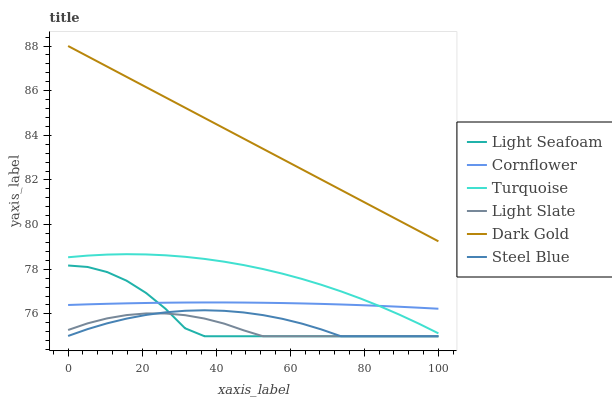Does Light Slate have the minimum area under the curve?
Answer yes or no. Yes. Does Dark Gold have the maximum area under the curve?
Answer yes or no. Yes. Does Turquoise have the minimum area under the curve?
Answer yes or no. No. Does Turquoise have the maximum area under the curve?
Answer yes or no. No. Is Dark Gold the smoothest?
Answer yes or no. Yes. Is Light Seafoam the roughest?
Answer yes or no. Yes. Is Turquoise the smoothest?
Answer yes or no. No. Is Turquoise the roughest?
Answer yes or no. No. Does Light Slate have the lowest value?
Answer yes or no. Yes. Does Turquoise have the lowest value?
Answer yes or no. No. Does Dark Gold have the highest value?
Answer yes or no. Yes. Does Turquoise have the highest value?
Answer yes or no. No. Is Steel Blue less than Cornflower?
Answer yes or no. Yes. Is Cornflower greater than Steel Blue?
Answer yes or no. Yes. Does Steel Blue intersect Light Seafoam?
Answer yes or no. Yes. Is Steel Blue less than Light Seafoam?
Answer yes or no. No. Is Steel Blue greater than Light Seafoam?
Answer yes or no. No. Does Steel Blue intersect Cornflower?
Answer yes or no. No. 